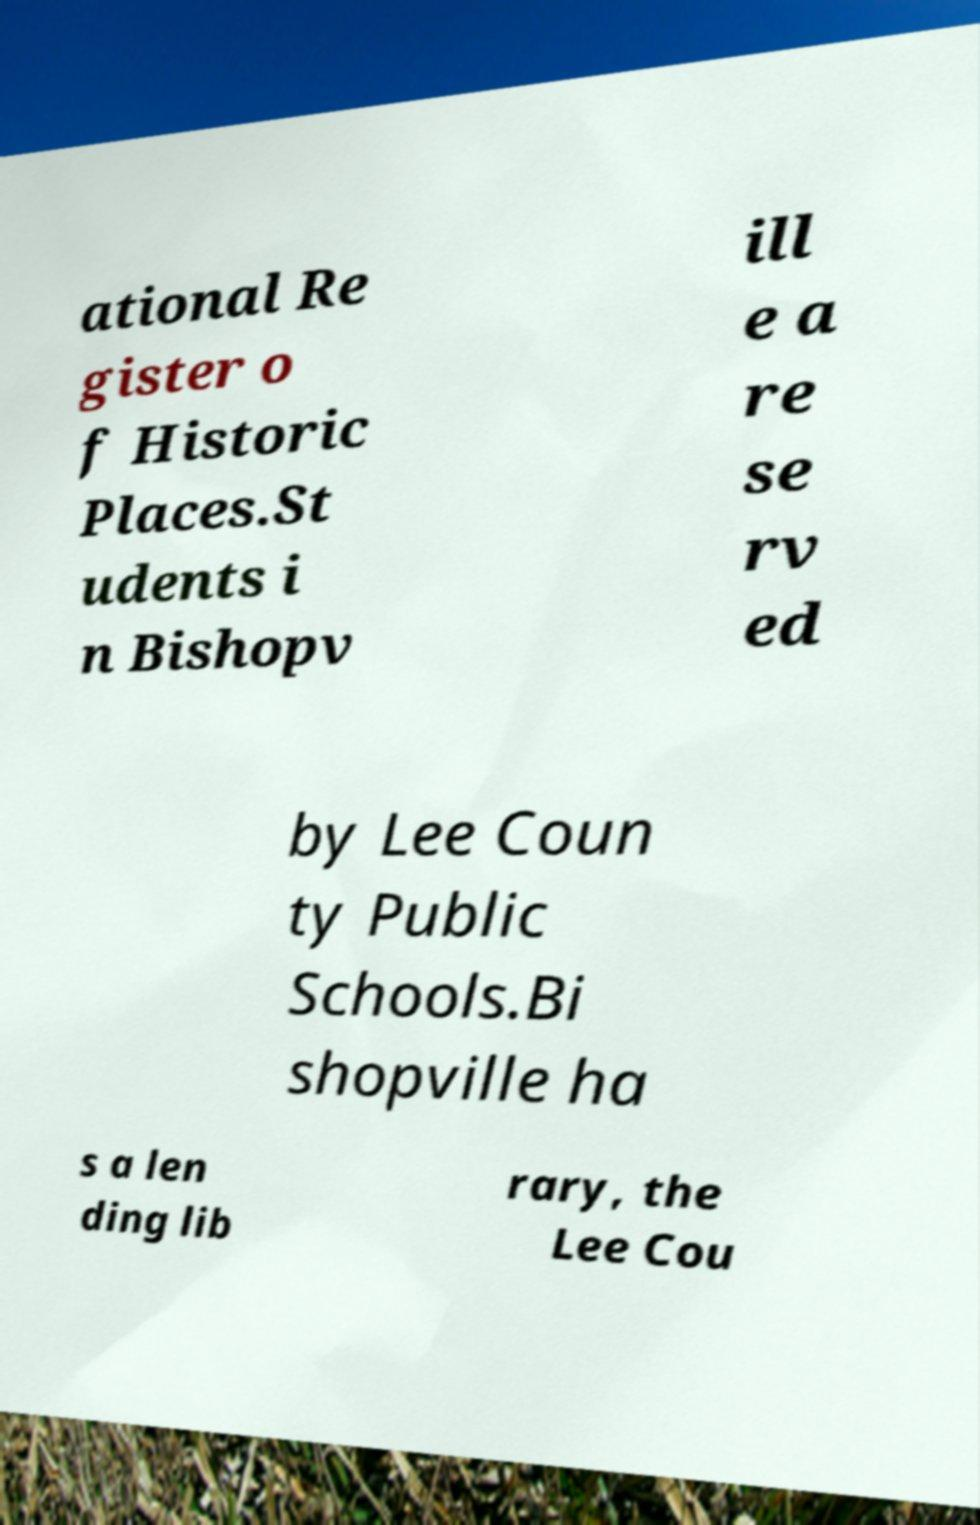Can you accurately transcribe the text from the provided image for me? ational Re gister o f Historic Places.St udents i n Bishopv ill e a re se rv ed by Lee Coun ty Public Schools.Bi shopville ha s a len ding lib rary, the Lee Cou 